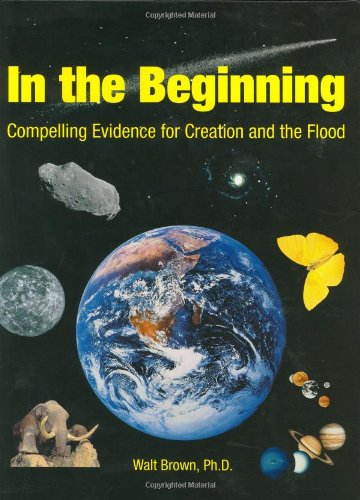What is the genre of this book? This book falls under the 'Christian Books & Bibles' genre, clearly aiming to appeal to readers interested in religious interpretations of Earth's origins and history. 